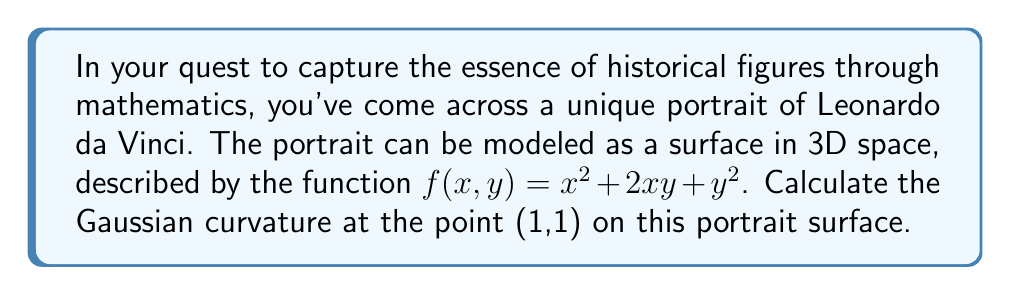Give your solution to this math problem. To calculate the Gaussian curvature of the surface at the point (1,1), we'll follow these steps:

1. The Gaussian curvature K is given by:
   $$K = \frac{LN - M^2}{EG - F^2}$$
   where L, M, N are coefficients of the second fundamental form, and E, F, G are coefficients of the first fundamental form.

2. First, let's calculate the partial derivatives:
   $$f_x = 2x + 2y$$
   $$f_y = 2x + 2y$$
   $$f_{xx} = 2$$
   $$f_{xy} = 2$$
   $$f_{yy} = 2$$

3. Now, we can calculate E, F, and G:
   $$E = 1 + f_x^2 = 1 + (2x + 2y)^2$$
   $$F = f_x f_y = (2x + 2y)^2$$
   $$G = 1 + f_y^2 = 1 + (2x + 2y)^2$$

4. The normal vector to the surface is:
   $$\vec{N} = \frac{(-f_x, -f_y, 1)}{\sqrt{1 + f_x^2 + f_y^2}}$$

5. Now we can calculate L, M, and N:
   $$L = \frac{f_{xx}}{\sqrt{1 + f_x^2 + f_y^2}} = \frac{2}{\sqrt{1 + (2x + 2y)^2}}$$
   $$M = \frac{f_{xy}}{\sqrt{1 + f_x^2 + f_y^2}} = \frac{2}{\sqrt{1 + (2x + 2y)^2}}$$
   $$N = \frac{f_{yy}}{\sqrt{1 + f_x^2 + f_y^2}} = \frac{2}{\sqrt{1 + (2x + 2y)^2}}$$

6. At the point (1,1):
   $$E = G = 1 + (2 + 2)^2 = 17$$
   $$F = 4^2 = 16$$
   $$L = M = N = \frac{2}{\sqrt{17}}$$

7. Substituting these values into the Gaussian curvature formula:
   $$K = \frac{(\frac{2}{\sqrt{17}})(\frac{2}{\sqrt{17}}) - (\frac{2}{\sqrt{17}})^2}{17 \cdot 17 - 16^2} = \frac{0}{17 \cdot 17 - 16^2} = 0$$
Answer: $K = 0$ 